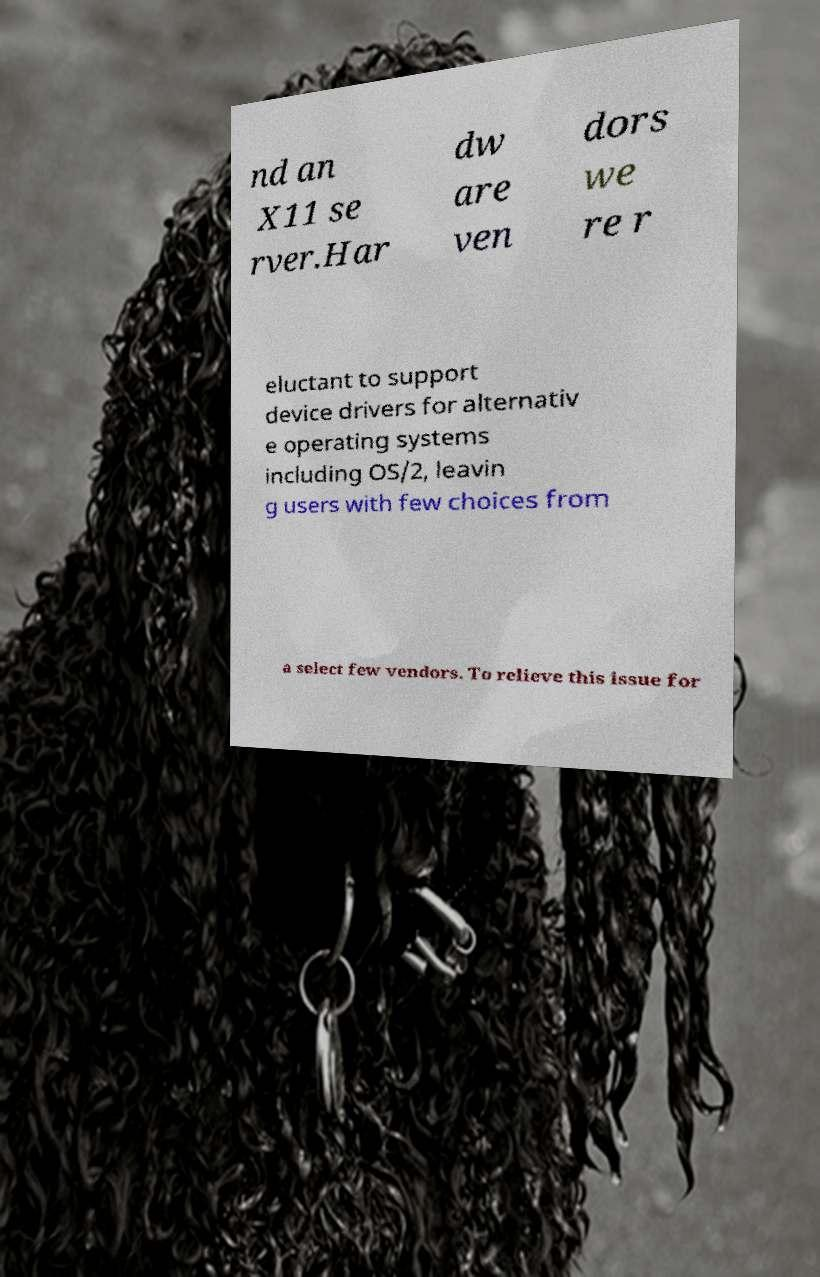Could you extract and type out the text from this image? nd an X11 se rver.Har dw are ven dors we re r eluctant to support device drivers for alternativ e operating systems including OS/2, leavin g users with few choices from a select few vendors. To relieve this issue for 